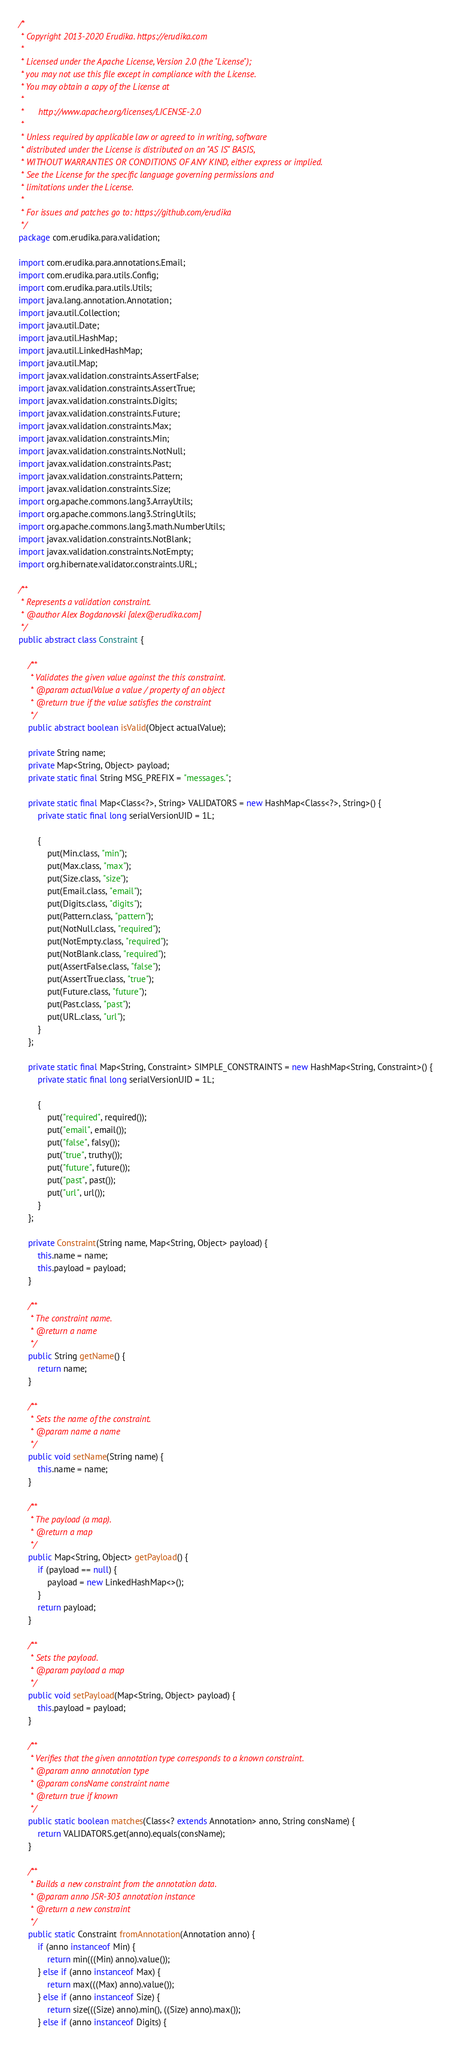<code> <loc_0><loc_0><loc_500><loc_500><_Java_>/*
 * Copyright 2013-2020 Erudika. https://erudika.com
 *
 * Licensed under the Apache License, Version 2.0 (the "License");
 * you may not use this file except in compliance with the License.
 * You may obtain a copy of the License at
 *
 *      http://www.apache.org/licenses/LICENSE-2.0
 *
 * Unless required by applicable law or agreed to in writing, software
 * distributed under the License is distributed on an "AS IS" BASIS,
 * WITHOUT WARRANTIES OR CONDITIONS OF ANY KIND, either express or implied.
 * See the License for the specific language governing permissions and
 * limitations under the License.
 *
 * For issues and patches go to: https://github.com/erudika
 */
package com.erudika.para.validation;

import com.erudika.para.annotations.Email;
import com.erudika.para.utils.Config;
import com.erudika.para.utils.Utils;
import java.lang.annotation.Annotation;
import java.util.Collection;
import java.util.Date;
import java.util.HashMap;
import java.util.LinkedHashMap;
import java.util.Map;
import javax.validation.constraints.AssertFalse;
import javax.validation.constraints.AssertTrue;
import javax.validation.constraints.Digits;
import javax.validation.constraints.Future;
import javax.validation.constraints.Max;
import javax.validation.constraints.Min;
import javax.validation.constraints.NotNull;
import javax.validation.constraints.Past;
import javax.validation.constraints.Pattern;
import javax.validation.constraints.Size;
import org.apache.commons.lang3.ArrayUtils;
import org.apache.commons.lang3.StringUtils;
import org.apache.commons.lang3.math.NumberUtils;
import javax.validation.constraints.NotBlank;
import javax.validation.constraints.NotEmpty;
import org.hibernate.validator.constraints.URL;

/**
 * Represents a validation constraint.
 * @author Alex Bogdanovski [alex@erudika.com]
 */
public abstract class Constraint {

	/**
	 * Validates the given value against the this constraint.
	 * @param actualValue a value / property of an object
	 * @return true if the value satisfies the constraint
	 */
	public abstract boolean isValid(Object actualValue);

	private String name;
	private Map<String, Object> payload;
	private static final String MSG_PREFIX = "messages.";

	private static final Map<Class<?>, String> VALIDATORS = new HashMap<Class<?>, String>() {
		private static final long serialVersionUID = 1L;

		{
			put(Min.class, "min");
			put(Max.class, "max");
			put(Size.class, "size");
			put(Email.class, "email");
			put(Digits.class, "digits");
			put(Pattern.class, "pattern");
			put(NotNull.class, "required");
			put(NotEmpty.class, "required");
			put(NotBlank.class, "required");
			put(AssertFalse.class, "false");
			put(AssertTrue.class, "true");
			put(Future.class, "future");
			put(Past.class, "past");
			put(URL.class, "url");
		}
	};

	private static final Map<String, Constraint> SIMPLE_CONSTRAINTS = new HashMap<String, Constraint>() {
		private static final long serialVersionUID = 1L;

		{
			put("required", required());
			put("email", email());
			put("false", falsy());
			put("true", truthy());
			put("future", future());
			put("past", past());
			put("url", url());
		}
	};

	private Constraint(String name, Map<String, Object> payload) {
		this.name = name;
		this.payload = payload;
	}

	/**
	 * The constraint name.
	 * @return a name
	 */
	public String getName() {
		return name;
	}

	/**
	 * Sets the name of the constraint.
	 * @param name a name
	 */
	public void setName(String name) {
		this.name = name;
	}

	/**
	 * The payload (a map).
	 * @return a map
	 */
	public Map<String, Object> getPayload() {
		if (payload == null) {
			payload = new LinkedHashMap<>();
		}
		return payload;
	}

	/**
	 * Sets the payload.
	 * @param payload a map
	 */
	public void setPayload(Map<String, Object> payload) {
		this.payload = payload;
	}

	/**
	 * Verifies that the given annotation type corresponds to a known constraint.
	 * @param anno annotation type
	 * @param consName constraint name
	 * @return true if known
	 */
	public static boolean matches(Class<? extends Annotation> anno, String consName) {
		return VALIDATORS.get(anno).equals(consName);
	}

	/**
	 * Builds a new constraint from the annotation data.
	 * @param anno JSR-303 annotation instance
	 * @return a new constraint
	 */
	public static Constraint fromAnnotation(Annotation anno) {
		if (anno instanceof Min) {
			return min(((Min) anno).value());
		} else if (anno instanceof Max) {
			return max(((Max) anno).value());
		} else if (anno instanceof Size) {
			return size(((Size) anno).min(), ((Size) anno).max());
		} else if (anno instanceof Digits) {</code> 